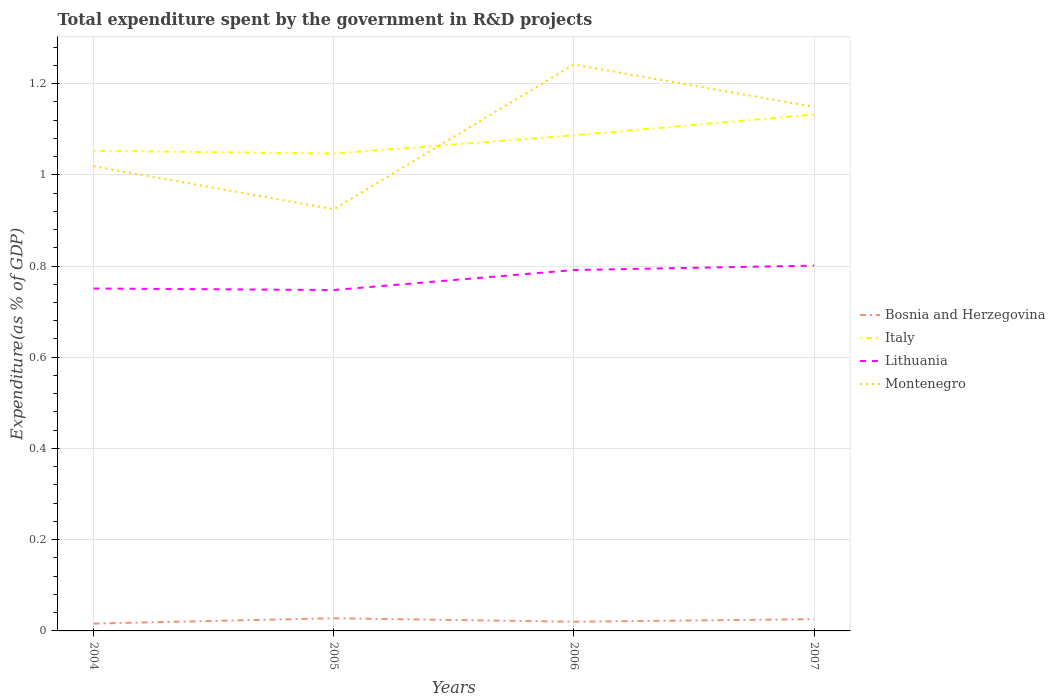Does the line corresponding to Lithuania intersect with the line corresponding to Italy?
Your answer should be very brief. No. Across all years, what is the maximum total expenditure spent by the government in R&D projects in Lithuania?
Ensure brevity in your answer.  0.75. In which year was the total expenditure spent by the government in R&D projects in Montenegro maximum?
Offer a very short reply. 2005. What is the total total expenditure spent by the government in R&D projects in Bosnia and Herzegovina in the graph?
Your answer should be very brief. -0.01. What is the difference between the highest and the second highest total expenditure spent by the government in R&D projects in Italy?
Your answer should be very brief. 0.09. Is the total expenditure spent by the government in R&D projects in Bosnia and Herzegovina strictly greater than the total expenditure spent by the government in R&D projects in Italy over the years?
Ensure brevity in your answer.  Yes. How many years are there in the graph?
Provide a succinct answer. 4. What is the difference between two consecutive major ticks on the Y-axis?
Your response must be concise. 0.2. Are the values on the major ticks of Y-axis written in scientific E-notation?
Ensure brevity in your answer.  No. What is the title of the graph?
Your response must be concise. Total expenditure spent by the government in R&D projects. Does "Tuvalu" appear as one of the legend labels in the graph?
Make the answer very short. No. What is the label or title of the X-axis?
Make the answer very short. Years. What is the label or title of the Y-axis?
Offer a very short reply. Expenditure(as % of GDP). What is the Expenditure(as % of GDP) of Bosnia and Herzegovina in 2004?
Make the answer very short. 0.02. What is the Expenditure(as % of GDP) in Italy in 2004?
Your response must be concise. 1.05. What is the Expenditure(as % of GDP) of Lithuania in 2004?
Keep it short and to the point. 0.75. What is the Expenditure(as % of GDP) in Montenegro in 2004?
Your response must be concise. 1.02. What is the Expenditure(as % of GDP) in Bosnia and Herzegovina in 2005?
Give a very brief answer. 0.03. What is the Expenditure(as % of GDP) of Italy in 2005?
Provide a succinct answer. 1.05. What is the Expenditure(as % of GDP) of Lithuania in 2005?
Your answer should be compact. 0.75. What is the Expenditure(as % of GDP) in Montenegro in 2005?
Offer a terse response. 0.92. What is the Expenditure(as % of GDP) in Bosnia and Herzegovina in 2006?
Offer a very short reply. 0.02. What is the Expenditure(as % of GDP) in Italy in 2006?
Give a very brief answer. 1.09. What is the Expenditure(as % of GDP) in Lithuania in 2006?
Give a very brief answer. 0.79. What is the Expenditure(as % of GDP) in Montenegro in 2006?
Give a very brief answer. 1.24. What is the Expenditure(as % of GDP) in Bosnia and Herzegovina in 2007?
Your answer should be very brief. 0.03. What is the Expenditure(as % of GDP) in Italy in 2007?
Give a very brief answer. 1.13. What is the Expenditure(as % of GDP) of Lithuania in 2007?
Give a very brief answer. 0.8. What is the Expenditure(as % of GDP) in Montenegro in 2007?
Your response must be concise. 1.15. Across all years, what is the maximum Expenditure(as % of GDP) of Bosnia and Herzegovina?
Offer a terse response. 0.03. Across all years, what is the maximum Expenditure(as % of GDP) in Italy?
Your response must be concise. 1.13. Across all years, what is the maximum Expenditure(as % of GDP) of Lithuania?
Provide a short and direct response. 0.8. Across all years, what is the maximum Expenditure(as % of GDP) of Montenegro?
Offer a very short reply. 1.24. Across all years, what is the minimum Expenditure(as % of GDP) of Bosnia and Herzegovina?
Ensure brevity in your answer.  0.02. Across all years, what is the minimum Expenditure(as % of GDP) in Italy?
Provide a succinct answer. 1.05. Across all years, what is the minimum Expenditure(as % of GDP) in Lithuania?
Your answer should be compact. 0.75. Across all years, what is the minimum Expenditure(as % of GDP) in Montenegro?
Give a very brief answer. 0.92. What is the total Expenditure(as % of GDP) of Bosnia and Herzegovina in the graph?
Your answer should be compact. 0.09. What is the total Expenditure(as % of GDP) of Italy in the graph?
Your answer should be compact. 4.32. What is the total Expenditure(as % of GDP) in Lithuania in the graph?
Your answer should be compact. 3.09. What is the total Expenditure(as % of GDP) in Montenegro in the graph?
Give a very brief answer. 4.33. What is the difference between the Expenditure(as % of GDP) in Bosnia and Herzegovina in 2004 and that in 2005?
Your response must be concise. -0.01. What is the difference between the Expenditure(as % of GDP) in Italy in 2004 and that in 2005?
Keep it short and to the point. 0.01. What is the difference between the Expenditure(as % of GDP) of Lithuania in 2004 and that in 2005?
Provide a succinct answer. 0. What is the difference between the Expenditure(as % of GDP) in Montenegro in 2004 and that in 2005?
Make the answer very short. 0.09. What is the difference between the Expenditure(as % of GDP) in Bosnia and Herzegovina in 2004 and that in 2006?
Provide a succinct answer. -0. What is the difference between the Expenditure(as % of GDP) of Italy in 2004 and that in 2006?
Keep it short and to the point. -0.03. What is the difference between the Expenditure(as % of GDP) of Lithuania in 2004 and that in 2006?
Offer a very short reply. -0.04. What is the difference between the Expenditure(as % of GDP) in Montenegro in 2004 and that in 2006?
Provide a succinct answer. -0.22. What is the difference between the Expenditure(as % of GDP) in Bosnia and Herzegovina in 2004 and that in 2007?
Make the answer very short. -0.01. What is the difference between the Expenditure(as % of GDP) in Italy in 2004 and that in 2007?
Provide a short and direct response. -0.08. What is the difference between the Expenditure(as % of GDP) in Lithuania in 2004 and that in 2007?
Your answer should be very brief. -0.05. What is the difference between the Expenditure(as % of GDP) in Montenegro in 2004 and that in 2007?
Keep it short and to the point. -0.13. What is the difference between the Expenditure(as % of GDP) in Bosnia and Herzegovina in 2005 and that in 2006?
Make the answer very short. 0.01. What is the difference between the Expenditure(as % of GDP) of Italy in 2005 and that in 2006?
Your answer should be compact. -0.04. What is the difference between the Expenditure(as % of GDP) of Lithuania in 2005 and that in 2006?
Give a very brief answer. -0.04. What is the difference between the Expenditure(as % of GDP) in Montenegro in 2005 and that in 2006?
Make the answer very short. -0.32. What is the difference between the Expenditure(as % of GDP) in Bosnia and Herzegovina in 2005 and that in 2007?
Offer a very short reply. 0. What is the difference between the Expenditure(as % of GDP) in Italy in 2005 and that in 2007?
Make the answer very short. -0.09. What is the difference between the Expenditure(as % of GDP) of Lithuania in 2005 and that in 2007?
Provide a short and direct response. -0.05. What is the difference between the Expenditure(as % of GDP) of Montenegro in 2005 and that in 2007?
Make the answer very short. -0.22. What is the difference between the Expenditure(as % of GDP) of Bosnia and Herzegovina in 2006 and that in 2007?
Provide a succinct answer. -0.01. What is the difference between the Expenditure(as % of GDP) in Italy in 2006 and that in 2007?
Your answer should be compact. -0.05. What is the difference between the Expenditure(as % of GDP) of Lithuania in 2006 and that in 2007?
Provide a succinct answer. -0.01. What is the difference between the Expenditure(as % of GDP) in Montenegro in 2006 and that in 2007?
Provide a short and direct response. 0.09. What is the difference between the Expenditure(as % of GDP) of Bosnia and Herzegovina in 2004 and the Expenditure(as % of GDP) of Italy in 2005?
Provide a short and direct response. -1.03. What is the difference between the Expenditure(as % of GDP) in Bosnia and Herzegovina in 2004 and the Expenditure(as % of GDP) in Lithuania in 2005?
Your response must be concise. -0.73. What is the difference between the Expenditure(as % of GDP) in Bosnia and Herzegovina in 2004 and the Expenditure(as % of GDP) in Montenegro in 2005?
Your answer should be compact. -0.91. What is the difference between the Expenditure(as % of GDP) of Italy in 2004 and the Expenditure(as % of GDP) of Lithuania in 2005?
Provide a succinct answer. 0.31. What is the difference between the Expenditure(as % of GDP) of Italy in 2004 and the Expenditure(as % of GDP) of Montenegro in 2005?
Provide a short and direct response. 0.13. What is the difference between the Expenditure(as % of GDP) in Lithuania in 2004 and the Expenditure(as % of GDP) in Montenegro in 2005?
Make the answer very short. -0.17. What is the difference between the Expenditure(as % of GDP) of Bosnia and Herzegovina in 2004 and the Expenditure(as % of GDP) of Italy in 2006?
Keep it short and to the point. -1.07. What is the difference between the Expenditure(as % of GDP) of Bosnia and Herzegovina in 2004 and the Expenditure(as % of GDP) of Lithuania in 2006?
Provide a short and direct response. -0.78. What is the difference between the Expenditure(as % of GDP) in Bosnia and Herzegovina in 2004 and the Expenditure(as % of GDP) in Montenegro in 2006?
Ensure brevity in your answer.  -1.23. What is the difference between the Expenditure(as % of GDP) of Italy in 2004 and the Expenditure(as % of GDP) of Lithuania in 2006?
Offer a very short reply. 0.26. What is the difference between the Expenditure(as % of GDP) in Italy in 2004 and the Expenditure(as % of GDP) in Montenegro in 2006?
Your response must be concise. -0.19. What is the difference between the Expenditure(as % of GDP) in Lithuania in 2004 and the Expenditure(as % of GDP) in Montenegro in 2006?
Provide a succinct answer. -0.49. What is the difference between the Expenditure(as % of GDP) in Bosnia and Herzegovina in 2004 and the Expenditure(as % of GDP) in Italy in 2007?
Your answer should be compact. -1.12. What is the difference between the Expenditure(as % of GDP) of Bosnia and Herzegovina in 2004 and the Expenditure(as % of GDP) of Lithuania in 2007?
Offer a very short reply. -0.78. What is the difference between the Expenditure(as % of GDP) of Bosnia and Herzegovina in 2004 and the Expenditure(as % of GDP) of Montenegro in 2007?
Give a very brief answer. -1.13. What is the difference between the Expenditure(as % of GDP) in Italy in 2004 and the Expenditure(as % of GDP) in Lithuania in 2007?
Provide a succinct answer. 0.25. What is the difference between the Expenditure(as % of GDP) in Italy in 2004 and the Expenditure(as % of GDP) in Montenegro in 2007?
Offer a very short reply. -0.1. What is the difference between the Expenditure(as % of GDP) in Lithuania in 2004 and the Expenditure(as % of GDP) in Montenegro in 2007?
Your answer should be very brief. -0.4. What is the difference between the Expenditure(as % of GDP) of Bosnia and Herzegovina in 2005 and the Expenditure(as % of GDP) of Italy in 2006?
Make the answer very short. -1.06. What is the difference between the Expenditure(as % of GDP) in Bosnia and Herzegovina in 2005 and the Expenditure(as % of GDP) in Lithuania in 2006?
Give a very brief answer. -0.76. What is the difference between the Expenditure(as % of GDP) in Bosnia and Herzegovina in 2005 and the Expenditure(as % of GDP) in Montenegro in 2006?
Ensure brevity in your answer.  -1.21. What is the difference between the Expenditure(as % of GDP) in Italy in 2005 and the Expenditure(as % of GDP) in Lithuania in 2006?
Your response must be concise. 0.26. What is the difference between the Expenditure(as % of GDP) in Italy in 2005 and the Expenditure(as % of GDP) in Montenegro in 2006?
Your answer should be very brief. -0.2. What is the difference between the Expenditure(as % of GDP) of Lithuania in 2005 and the Expenditure(as % of GDP) of Montenegro in 2006?
Offer a terse response. -0.49. What is the difference between the Expenditure(as % of GDP) in Bosnia and Herzegovina in 2005 and the Expenditure(as % of GDP) in Italy in 2007?
Ensure brevity in your answer.  -1.1. What is the difference between the Expenditure(as % of GDP) of Bosnia and Herzegovina in 2005 and the Expenditure(as % of GDP) of Lithuania in 2007?
Give a very brief answer. -0.77. What is the difference between the Expenditure(as % of GDP) of Bosnia and Herzegovina in 2005 and the Expenditure(as % of GDP) of Montenegro in 2007?
Provide a short and direct response. -1.12. What is the difference between the Expenditure(as % of GDP) in Italy in 2005 and the Expenditure(as % of GDP) in Lithuania in 2007?
Your answer should be compact. 0.25. What is the difference between the Expenditure(as % of GDP) in Italy in 2005 and the Expenditure(as % of GDP) in Montenegro in 2007?
Make the answer very short. -0.1. What is the difference between the Expenditure(as % of GDP) in Lithuania in 2005 and the Expenditure(as % of GDP) in Montenegro in 2007?
Make the answer very short. -0.4. What is the difference between the Expenditure(as % of GDP) of Bosnia and Herzegovina in 2006 and the Expenditure(as % of GDP) of Italy in 2007?
Give a very brief answer. -1.11. What is the difference between the Expenditure(as % of GDP) of Bosnia and Herzegovina in 2006 and the Expenditure(as % of GDP) of Lithuania in 2007?
Your answer should be very brief. -0.78. What is the difference between the Expenditure(as % of GDP) of Bosnia and Herzegovina in 2006 and the Expenditure(as % of GDP) of Montenegro in 2007?
Your answer should be compact. -1.13. What is the difference between the Expenditure(as % of GDP) in Italy in 2006 and the Expenditure(as % of GDP) in Lithuania in 2007?
Give a very brief answer. 0.29. What is the difference between the Expenditure(as % of GDP) in Italy in 2006 and the Expenditure(as % of GDP) in Montenegro in 2007?
Provide a succinct answer. -0.06. What is the difference between the Expenditure(as % of GDP) in Lithuania in 2006 and the Expenditure(as % of GDP) in Montenegro in 2007?
Provide a succinct answer. -0.36. What is the average Expenditure(as % of GDP) of Bosnia and Herzegovina per year?
Make the answer very short. 0.02. What is the average Expenditure(as % of GDP) in Italy per year?
Ensure brevity in your answer.  1.08. What is the average Expenditure(as % of GDP) of Lithuania per year?
Ensure brevity in your answer.  0.77. What is the average Expenditure(as % of GDP) in Montenegro per year?
Your answer should be compact. 1.08. In the year 2004, what is the difference between the Expenditure(as % of GDP) in Bosnia and Herzegovina and Expenditure(as % of GDP) in Italy?
Offer a very short reply. -1.04. In the year 2004, what is the difference between the Expenditure(as % of GDP) in Bosnia and Herzegovina and Expenditure(as % of GDP) in Lithuania?
Your response must be concise. -0.73. In the year 2004, what is the difference between the Expenditure(as % of GDP) in Bosnia and Herzegovina and Expenditure(as % of GDP) in Montenegro?
Give a very brief answer. -1. In the year 2004, what is the difference between the Expenditure(as % of GDP) of Italy and Expenditure(as % of GDP) of Lithuania?
Make the answer very short. 0.3. In the year 2004, what is the difference between the Expenditure(as % of GDP) of Italy and Expenditure(as % of GDP) of Montenegro?
Offer a very short reply. 0.03. In the year 2004, what is the difference between the Expenditure(as % of GDP) of Lithuania and Expenditure(as % of GDP) of Montenegro?
Make the answer very short. -0.27. In the year 2005, what is the difference between the Expenditure(as % of GDP) of Bosnia and Herzegovina and Expenditure(as % of GDP) of Italy?
Ensure brevity in your answer.  -1.02. In the year 2005, what is the difference between the Expenditure(as % of GDP) of Bosnia and Herzegovina and Expenditure(as % of GDP) of Lithuania?
Keep it short and to the point. -0.72. In the year 2005, what is the difference between the Expenditure(as % of GDP) in Bosnia and Herzegovina and Expenditure(as % of GDP) in Montenegro?
Your answer should be very brief. -0.9. In the year 2005, what is the difference between the Expenditure(as % of GDP) of Italy and Expenditure(as % of GDP) of Lithuania?
Provide a succinct answer. 0.3. In the year 2005, what is the difference between the Expenditure(as % of GDP) in Italy and Expenditure(as % of GDP) in Montenegro?
Keep it short and to the point. 0.12. In the year 2005, what is the difference between the Expenditure(as % of GDP) of Lithuania and Expenditure(as % of GDP) of Montenegro?
Make the answer very short. -0.18. In the year 2006, what is the difference between the Expenditure(as % of GDP) of Bosnia and Herzegovina and Expenditure(as % of GDP) of Italy?
Offer a very short reply. -1.07. In the year 2006, what is the difference between the Expenditure(as % of GDP) in Bosnia and Herzegovina and Expenditure(as % of GDP) in Lithuania?
Your answer should be very brief. -0.77. In the year 2006, what is the difference between the Expenditure(as % of GDP) of Bosnia and Herzegovina and Expenditure(as % of GDP) of Montenegro?
Your response must be concise. -1.22. In the year 2006, what is the difference between the Expenditure(as % of GDP) in Italy and Expenditure(as % of GDP) in Lithuania?
Keep it short and to the point. 0.3. In the year 2006, what is the difference between the Expenditure(as % of GDP) in Italy and Expenditure(as % of GDP) in Montenegro?
Give a very brief answer. -0.16. In the year 2006, what is the difference between the Expenditure(as % of GDP) of Lithuania and Expenditure(as % of GDP) of Montenegro?
Ensure brevity in your answer.  -0.45. In the year 2007, what is the difference between the Expenditure(as % of GDP) in Bosnia and Herzegovina and Expenditure(as % of GDP) in Italy?
Provide a succinct answer. -1.11. In the year 2007, what is the difference between the Expenditure(as % of GDP) in Bosnia and Herzegovina and Expenditure(as % of GDP) in Lithuania?
Your response must be concise. -0.78. In the year 2007, what is the difference between the Expenditure(as % of GDP) in Bosnia and Herzegovina and Expenditure(as % of GDP) in Montenegro?
Ensure brevity in your answer.  -1.12. In the year 2007, what is the difference between the Expenditure(as % of GDP) in Italy and Expenditure(as % of GDP) in Lithuania?
Your answer should be very brief. 0.33. In the year 2007, what is the difference between the Expenditure(as % of GDP) in Italy and Expenditure(as % of GDP) in Montenegro?
Provide a succinct answer. -0.02. In the year 2007, what is the difference between the Expenditure(as % of GDP) in Lithuania and Expenditure(as % of GDP) in Montenegro?
Your response must be concise. -0.35. What is the ratio of the Expenditure(as % of GDP) in Bosnia and Herzegovina in 2004 to that in 2005?
Make the answer very short. 0.58. What is the ratio of the Expenditure(as % of GDP) of Lithuania in 2004 to that in 2005?
Keep it short and to the point. 1. What is the ratio of the Expenditure(as % of GDP) in Montenegro in 2004 to that in 2005?
Keep it short and to the point. 1.1. What is the ratio of the Expenditure(as % of GDP) in Bosnia and Herzegovina in 2004 to that in 2006?
Offer a very short reply. 0.8. What is the ratio of the Expenditure(as % of GDP) in Italy in 2004 to that in 2006?
Provide a short and direct response. 0.97. What is the ratio of the Expenditure(as % of GDP) in Lithuania in 2004 to that in 2006?
Keep it short and to the point. 0.95. What is the ratio of the Expenditure(as % of GDP) of Montenegro in 2004 to that in 2006?
Provide a succinct answer. 0.82. What is the ratio of the Expenditure(as % of GDP) in Bosnia and Herzegovina in 2004 to that in 2007?
Your response must be concise. 0.63. What is the ratio of the Expenditure(as % of GDP) in Italy in 2004 to that in 2007?
Keep it short and to the point. 0.93. What is the ratio of the Expenditure(as % of GDP) in Lithuania in 2004 to that in 2007?
Your answer should be very brief. 0.94. What is the ratio of the Expenditure(as % of GDP) of Montenegro in 2004 to that in 2007?
Your answer should be compact. 0.89. What is the ratio of the Expenditure(as % of GDP) of Bosnia and Herzegovina in 2005 to that in 2006?
Give a very brief answer. 1.38. What is the ratio of the Expenditure(as % of GDP) in Italy in 2005 to that in 2006?
Make the answer very short. 0.96. What is the ratio of the Expenditure(as % of GDP) in Lithuania in 2005 to that in 2006?
Offer a very short reply. 0.94. What is the ratio of the Expenditure(as % of GDP) of Montenegro in 2005 to that in 2006?
Ensure brevity in your answer.  0.74. What is the ratio of the Expenditure(as % of GDP) in Bosnia and Herzegovina in 2005 to that in 2007?
Keep it short and to the point. 1.08. What is the ratio of the Expenditure(as % of GDP) of Italy in 2005 to that in 2007?
Your answer should be very brief. 0.92. What is the ratio of the Expenditure(as % of GDP) in Lithuania in 2005 to that in 2007?
Keep it short and to the point. 0.93. What is the ratio of the Expenditure(as % of GDP) of Montenegro in 2005 to that in 2007?
Make the answer very short. 0.8. What is the ratio of the Expenditure(as % of GDP) in Bosnia and Herzegovina in 2006 to that in 2007?
Offer a very short reply. 0.78. What is the ratio of the Expenditure(as % of GDP) in Italy in 2006 to that in 2007?
Provide a succinct answer. 0.96. What is the ratio of the Expenditure(as % of GDP) of Lithuania in 2006 to that in 2007?
Provide a short and direct response. 0.99. What is the ratio of the Expenditure(as % of GDP) in Montenegro in 2006 to that in 2007?
Your answer should be compact. 1.08. What is the difference between the highest and the second highest Expenditure(as % of GDP) of Bosnia and Herzegovina?
Your answer should be very brief. 0. What is the difference between the highest and the second highest Expenditure(as % of GDP) of Italy?
Offer a very short reply. 0.05. What is the difference between the highest and the second highest Expenditure(as % of GDP) in Lithuania?
Keep it short and to the point. 0.01. What is the difference between the highest and the second highest Expenditure(as % of GDP) of Montenegro?
Ensure brevity in your answer.  0.09. What is the difference between the highest and the lowest Expenditure(as % of GDP) in Bosnia and Herzegovina?
Keep it short and to the point. 0.01. What is the difference between the highest and the lowest Expenditure(as % of GDP) in Italy?
Your response must be concise. 0.09. What is the difference between the highest and the lowest Expenditure(as % of GDP) in Lithuania?
Your response must be concise. 0.05. What is the difference between the highest and the lowest Expenditure(as % of GDP) of Montenegro?
Give a very brief answer. 0.32. 